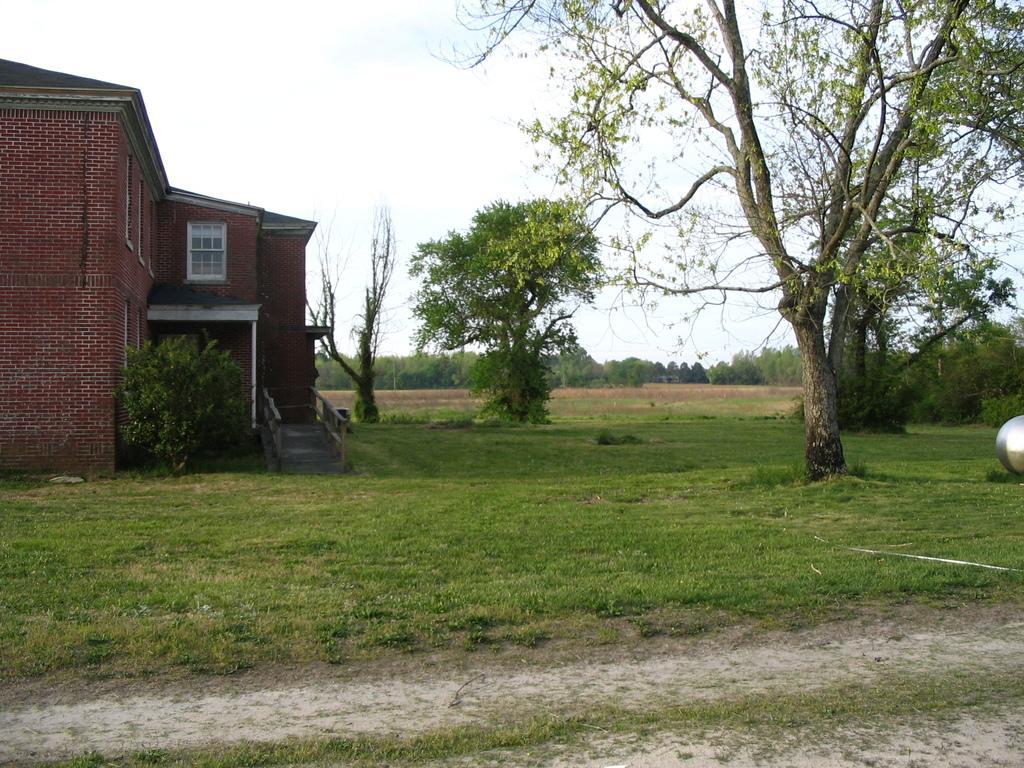Could you give a brief overview of what you see in this image? Land is covered with grass. Building with windows. In-front of this building there is a plant and trees. Far there are a number of trees.  